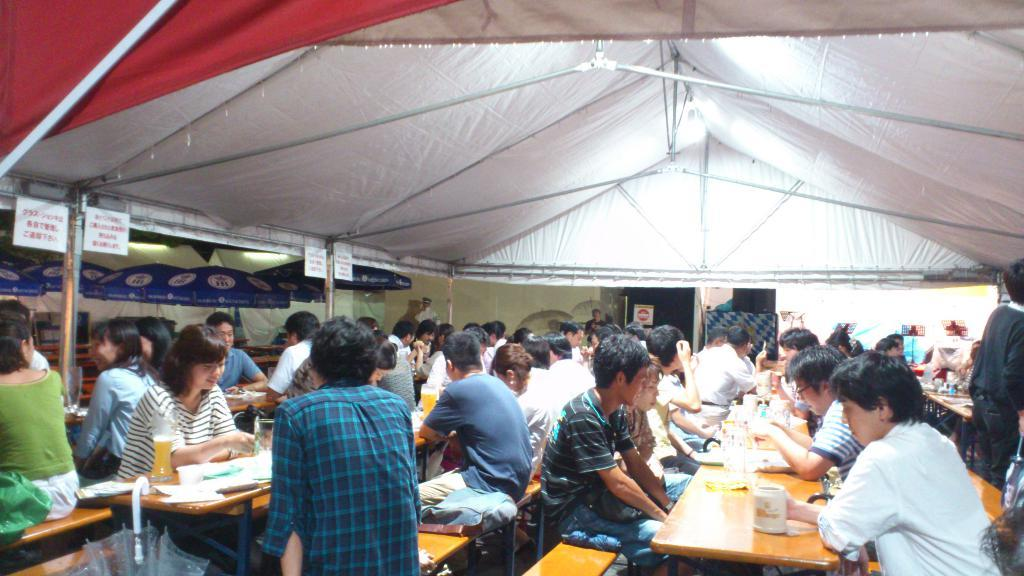What are the people in the image doing? There is a group of people sitting on chairs in the image. What is in front of the group? There is a table in front of the group. What can be found on the table? There are objects on the table. What is providing light in the image? There is a light above the group. What additional object is present in the image? There is an umbrella in the image. Can you see any bikes driving around the lake in the image? There is no lake or bikes driving in the image; it features a group of people sitting on chairs with a table, objects, a light, and an umbrella. 